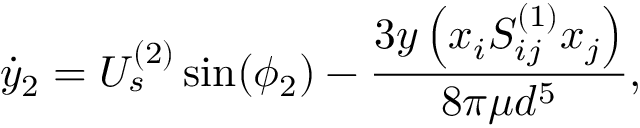<formula> <loc_0><loc_0><loc_500><loc_500>\dot { y } _ { 2 } = U _ { s } ^ { ( 2 ) } \sin ( \phi _ { 2 } ) - \frac { 3 y \left ( x _ { i } S _ { i j } ^ { ( 1 ) } x _ { j } \right ) } { 8 \pi \mu d ^ { 5 } } ,</formula> 